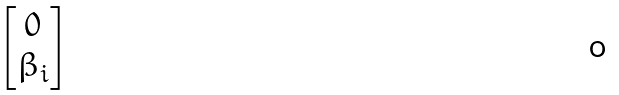<formula> <loc_0><loc_0><loc_500><loc_500>\begin{bmatrix} 0 \\ \beta _ { i } \end{bmatrix}</formula> 